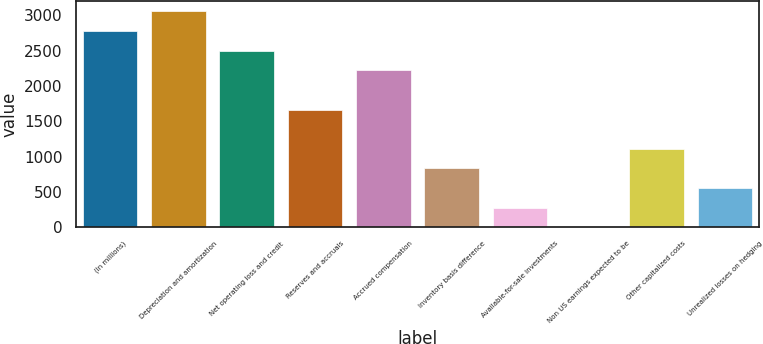Convert chart to OTSL. <chart><loc_0><loc_0><loc_500><loc_500><bar_chart><fcel>(In millions)<fcel>Depreciation and amortization<fcel>Net operating loss and credit<fcel>Reserves and accruals<fcel>Accrued compensation<fcel>Inventory basis difference<fcel>Available-for-sale investments<fcel>Non US earnings expected to be<fcel>Other capitalized costs<fcel>Unrealized losses on hedging<nl><fcel>2778.3<fcel>3055.97<fcel>2500.63<fcel>1667.62<fcel>2222.96<fcel>834.61<fcel>279.27<fcel>1.6<fcel>1112.28<fcel>556.94<nl></chart> 